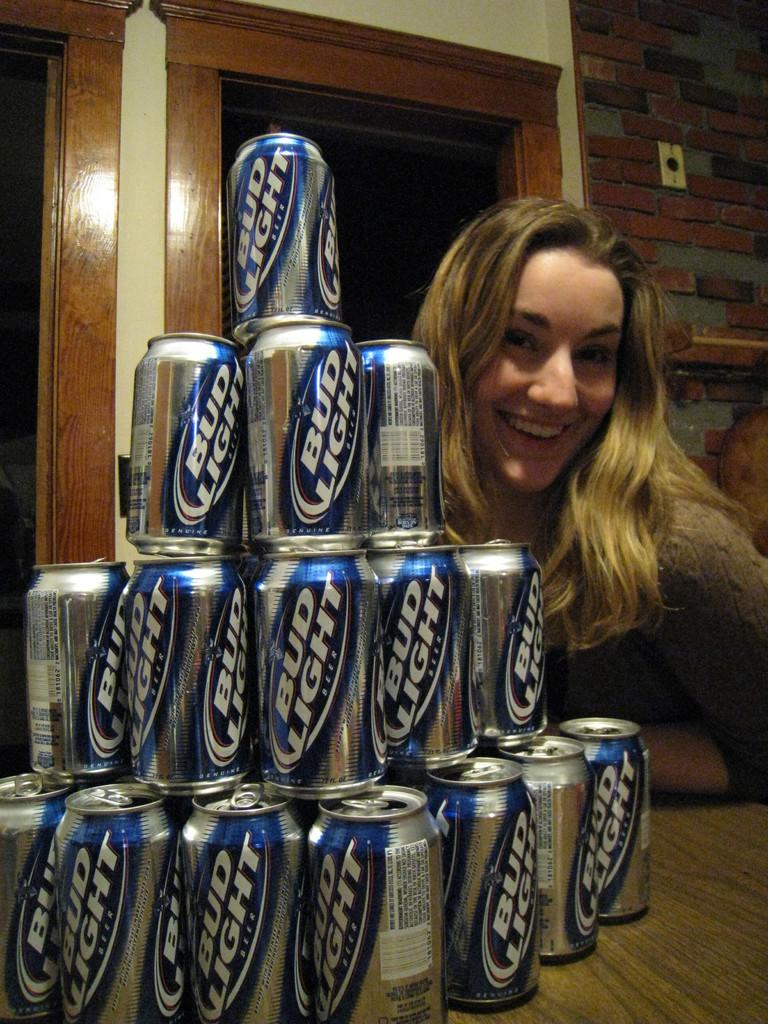<image>
Describe the image concisely. Bud light beer cans stacked in a display beside a smiling model. 